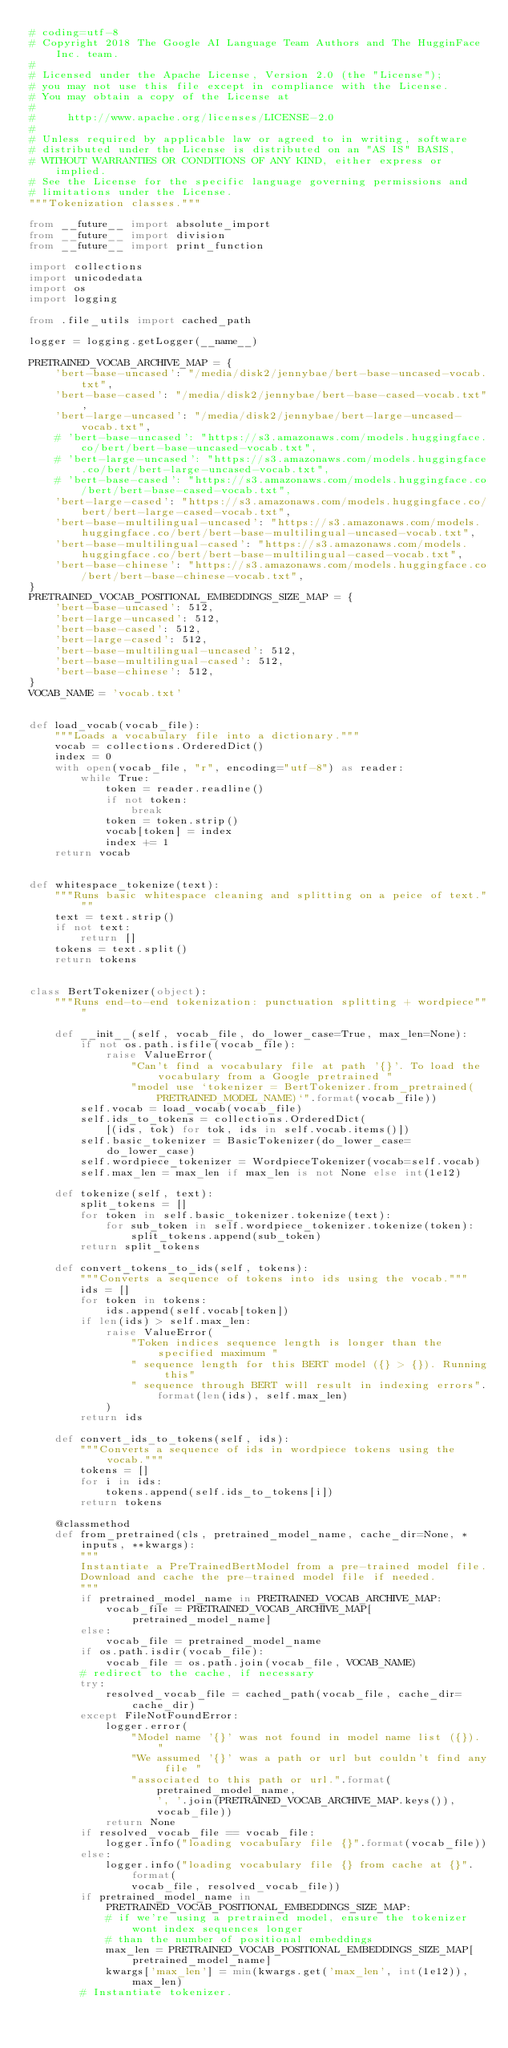Convert code to text. <code><loc_0><loc_0><loc_500><loc_500><_Python_># coding=utf-8
# Copyright 2018 The Google AI Language Team Authors and The HugginFace Inc. team.
#
# Licensed under the Apache License, Version 2.0 (the "License");
# you may not use this file except in compliance with the License.
# You may obtain a copy of the License at
#
#     http://www.apache.org/licenses/LICENSE-2.0
#
# Unless required by applicable law or agreed to in writing, software
# distributed under the License is distributed on an "AS IS" BASIS,
# WITHOUT WARRANTIES OR CONDITIONS OF ANY KIND, either express or implied.
# See the License for the specific language governing permissions and
# limitations under the License.
"""Tokenization classes."""

from __future__ import absolute_import
from __future__ import division
from __future__ import print_function

import collections
import unicodedata
import os
import logging

from .file_utils import cached_path

logger = logging.getLogger(__name__)

PRETRAINED_VOCAB_ARCHIVE_MAP = {
    'bert-base-uncased': "/media/disk2/jennybae/bert-base-uncased-vocab.txt",
    'bert-base-cased': "/media/disk2/jennybae/bert-base-cased-vocab.txt",
    'bert-large-uncased': "/media/disk2/jennybae/bert-large-uncased-vocab.txt",
    # 'bert-base-uncased': "https://s3.amazonaws.com/models.huggingface.co/bert/bert-base-uncased-vocab.txt",
    # 'bert-large-uncased': "https://s3.amazonaws.com/models.huggingface.co/bert/bert-large-uncased-vocab.txt",
    # 'bert-base-cased': "https://s3.amazonaws.com/models.huggingface.co/bert/bert-base-cased-vocab.txt",
    'bert-large-cased': "https://s3.amazonaws.com/models.huggingface.co/bert/bert-large-cased-vocab.txt",
    'bert-base-multilingual-uncased': "https://s3.amazonaws.com/models.huggingface.co/bert/bert-base-multilingual-uncased-vocab.txt",
    'bert-base-multilingual-cased': "https://s3.amazonaws.com/models.huggingface.co/bert/bert-base-multilingual-cased-vocab.txt",
    'bert-base-chinese': "https://s3.amazonaws.com/models.huggingface.co/bert/bert-base-chinese-vocab.txt",
}
PRETRAINED_VOCAB_POSITIONAL_EMBEDDINGS_SIZE_MAP = {
    'bert-base-uncased': 512,
    'bert-large-uncased': 512,
    'bert-base-cased': 512,
    'bert-large-cased': 512,
    'bert-base-multilingual-uncased': 512,
    'bert-base-multilingual-cased': 512,
    'bert-base-chinese': 512,
}
VOCAB_NAME = 'vocab.txt'


def load_vocab(vocab_file):
    """Loads a vocabulary file into a dictionary."""
    vocab = collections.OrderedDict()
    index = 0
    with open(vocab_file, "r", encoding="utf-8") as reader:
        while True:
            token = reader.readline()
            if not token:
                break
            token = token.strip()
            vocab[token] = index
            index += 1
    return vocab


def whitespace_tokenize(text):
    """Runs basic whitespace cleaning and splitting on a peice of text."""
    text = text.strip()
    if not text:
        return []
    tokens = text.split()
    return tokens


class BertTokenizer(object):
    """Runs end-to-end tokenization: punctuation splitting + wordpiece"""

    def __init__(self, vocab_file, do_lower_case=True, max_len=None):
        if not os.path.isfile(vocab_file):
            raise ValueError(
                "Can't find a vocabulary file at path '{}'. To load the vocabulary from a Google pretrained "
                "model use `tokenizer = BertTokenizer.from_pretrained(PRETRAINED_MODEL_NAME)`".format(vocab_file))
        self.vocab = load_vocab(vocab_file)
        self.ids_to_tokens = collections.OrderedDict(
            [(ids, tok) for tok, ids in self.vocab.items()])
        self.basic_tokenizer = BasicTokenizer(do_lower_case=do_lower_case)
        self.wordpiece_tokenizer = WordpieceTokenizer(vocab=self.vocab)
        self.max_len = max_len if max_len is not None else int(1e12)

    def tokenize(self, text):
        split_tokens = []
        for token in self.basic_tokenizer.tokenize(text):
            for sub_token in self.wordpiece_tokenizer.tokenize(token):
                split_tokens.append(sub_token)
        return split_tokens

    def convert_tokens_to_ids(self, tokens):
        """Converts a sequence of tokens into ids using the vocab."""
        ids = []
        for token in tokens:
            ids.append(self.vocab[token])
        if len(ids) > self.max_len:
            raise ValueError(
                "Token indices sequence length is longer than the specified maximum "
                " sequence length for this BERT model ({} > {}). Running this"
                " sequence through BERT will result in indexing errors".format(len(ids), self.max_len)
            )
        return ids

    def convert_ids_to_tokens(self, ids):
        """Converts a sequence of ids in wordpiece tokens using the vocab."""
        tokens = []
        for i in ids:
            tokens.append(self.ids_to_tokens[i])
        return tokens

    @classmethod
    def from_pretrained(cls, pretrained_model_name, cache_dir=None, *inputs, **kwargs):
        """
        Instantiate a PreTrainedBertModel from a pre-trained model file.
        Download and cache the pre-trained model file if needed.
        """
        if pretrained_model_name in PRETRAINED_VOCAB_ARCHIVE_MAP:
            vocab_file = PRETRAINED_VOCAB_ARCHIVE_MAP[pretrained_model_name]
        else:
            vocab_file = pretrained_model_name
        if os.path.isdir(vocab_file):
            vocab_file = os.path.join(vocab_file, VOCAB_NAME)
        # redirect to the cache, if necessary
        try:
            resolved_vocab_file = cached_path(vocab_file, cache_dir=cache_dir)
        except FileNotFoundError:
            logger.error(
                "Model name '{}' was not found in model name list ({}). "
                "We assumed '{}' was a path or url but couldn't find any file "
                "associated to this path or url.".format(
                    pretrained_model_name,
                    ', '.join(PRETRAINED_VOCAB_ARCHIVE_MAP.keys()),
                    vocab_file))
            return None
        if resolved_vocab_file == vocab_file:
            logger.info("loading vocabulary file {}".format(vocab_file))
        else:
            logger.info("loading vocabulary file {} from cache at {}".format(
                vocab_file, resolved_vocab_file))
        if pretrained_model_name in PRETRAINED_VOCAB_POSITIONAL_EMBEDDINGS_SIZE_MAP:
            # if we're using a pretrained model, ensure the tokenizer wont index sequences longer
            # than the number of positional embeddings
            max_len = PRETRAINED_VOCAB_POSITIONAL_EMBEDDINGS_SIZE_MAP[pretrained_model_name]
            kwargs['max_len'] = min(kwargs.get('max_len', int(1e12)), max_len)
        # Instantiate tokenizer.</code> 